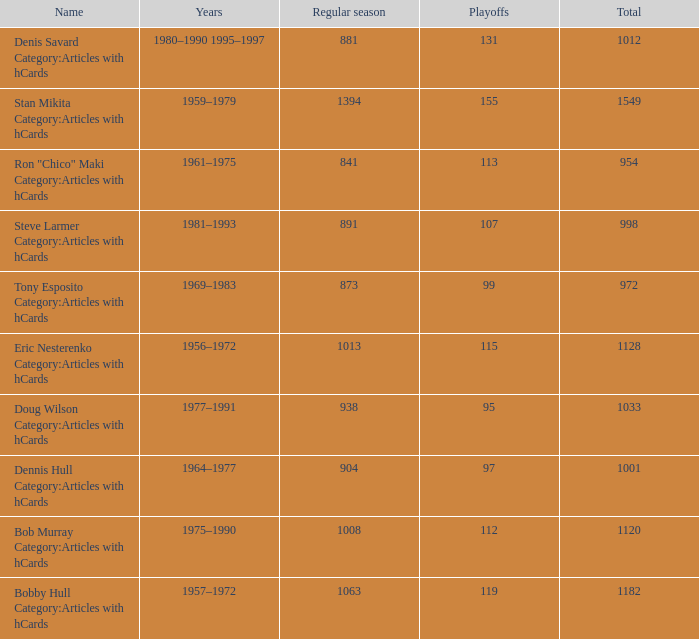What is the years when playoffs is 115? 1956–1972. 